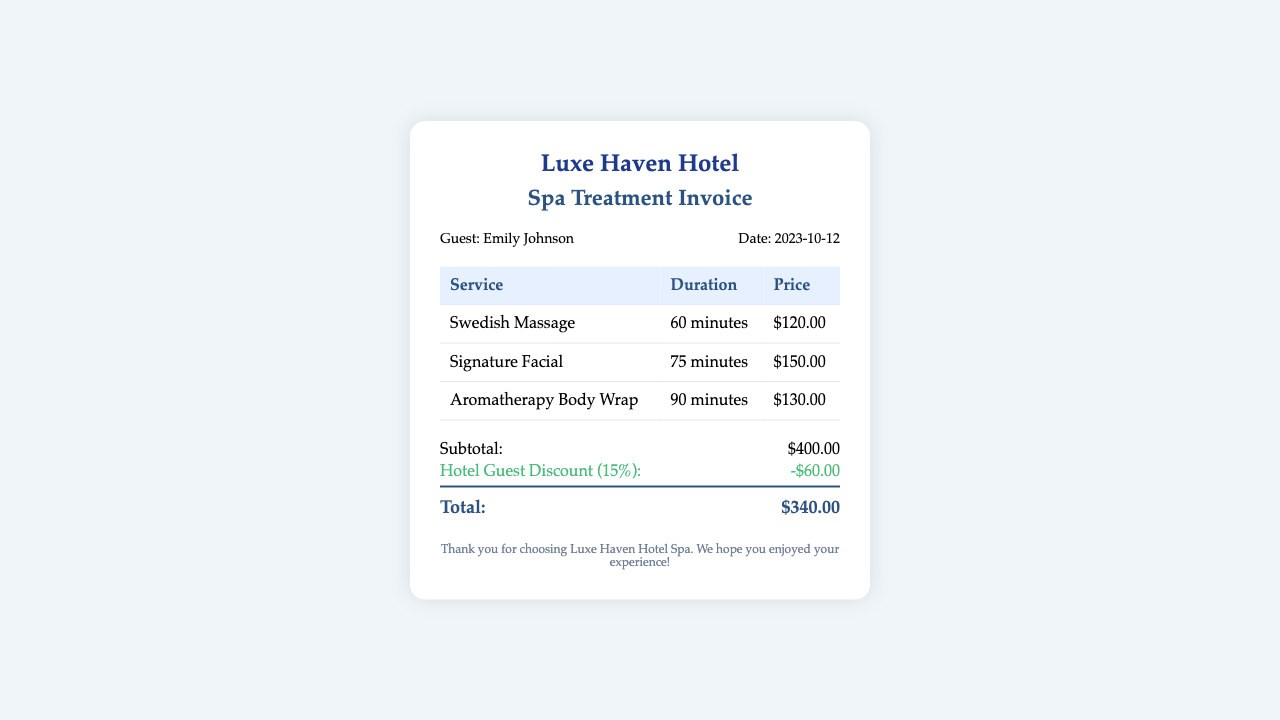What is the guest's name? The guest's name can be found in the invoice details section, which states "Guest: Emily Johnson".
Answer: Emily Johnson What services were received? The list of services in the table includes "Swedish Massage", "Signature Facial", and "Aromatherapy Body Wrap".
Answer: Swedish Massage, Signature Facial, Aromatherapy Body Wrap What was the total amount charged? The total amount is detailed in the total section, which shows "Total: $340.00".
Answer: $340.00 What discount did the hotel guest receive? The invoice mentions a "Hotel Guest Discount (15%): -$60.00" indicating the discount applied.
Answer: -$60.00 How long was the Aromatherapy Body Wrap? The duration for the Aromatherapy Body Wrap is listed in the table as "90 minutes".
Answer: 90 minutes What is the subtotal before discounts? The subtotal before applying discounts is provided in the total section, shown as "Subtotal: $400.00".
Answer: $400.00 When was the spa treatment date? The date of the treatment can be found in the invoice details, which states "Date: 2023-10-12".
Answer: 2023-10-12 How many minutes was the Signature Facial? The duration of the Signature Facial can be found in the services table, which states "75 minutes".
Answer: 75 minutes Which spa service has the highest price? The highest price among the services can be determined by comparing the prices listed: $120.00, $150.00, and $130.00.
Answer: Signature Facial 